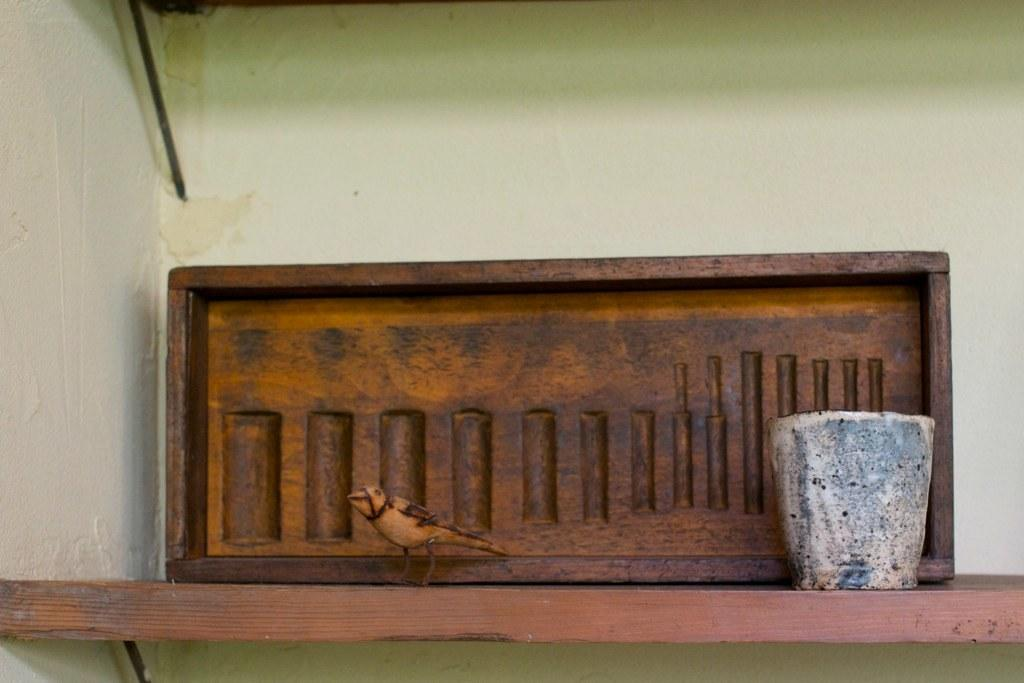What object is present in the image that is typically used for cooking or storage? There is a pot in the image. What type of toy is visible in the image? There is a bird toy in the image. What is the material of the structure in the image? The structure in the image is made of wooden blocks. How are the pot, bird toy, and wooden block structure arranged in the image? They are all kept on a wooden stand. What type of quilt is being used to shock the bird toy in the image? There is no quilt or shocking action involving a bird toy present in the image. How many times is the bird toy lifted up and down in the image? There is no lifting action involving the bird toy in the image. 